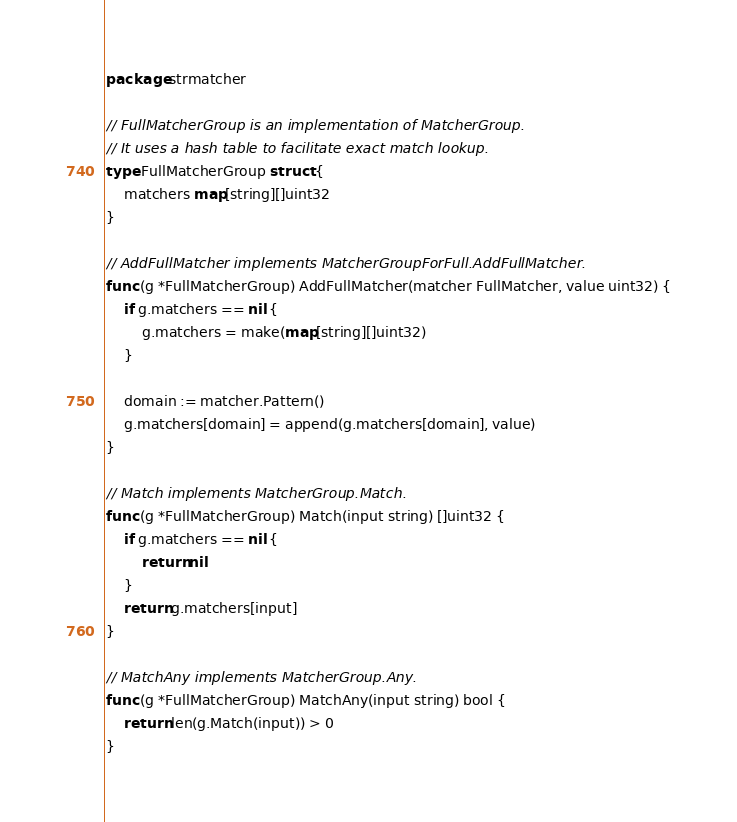Convert code to text. <code><loc_0><loc_0><loc_500><loc_500><_Go_>package strmatcher

// FullMatcherGroup is an implementation of MatcherGroup.
// It uses a hash table to facilitate exact match lookup.
type FullMatcherGroup struct {
	matchers map[string][]uint32
}

// AddFullMatcher implements MatcherGroupForFull.AddFullMatcher.
func (g *FullMatcherGroup) AddFullMatcher(matcher FullMatcher, value uint32) {
	if g.matchers == nil {
		g.matchers = make(map[string][]uint32)
	}

	domain := matcher.Pattern()
	g.matchers[domain] = append(g.matchers[domain], value)
}

// Match implements MatcherGroup.Match.
func (g *FullMatcherGroup) Match(input string) []uint32 {
	if g.matchers == nil {
		return nil
	}
	return g.matchers[input]
}

// MatchAny implements MatcherGroup.Any.
func (g *FullMatcherGroup) MatchAny(input string) bool {
	return len(g.Match(input)) > 0
}
</code> 